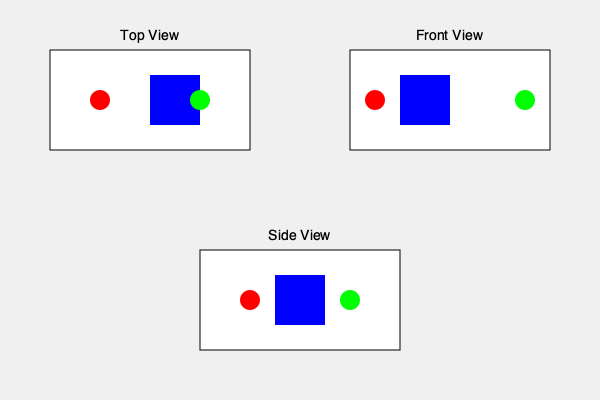Based on the given 2D views of a Goo Goo Dolls stage setup, which of the following 3D configurations is correct?

A) Red spotlight on the left, blue cube in the center, green spotlight on the right
B) Green spotlight on the left, blue cube in the center, red spotlight on the right
C) Blue cube on the left, red spotlight in the center, green spotlight on the right
D) Red spotlight on the left, green spotlight in the center, blue cube on the right To determine the correct 3D stage setup, we need to analyze each 2D view and combine the information:

1. Top View:
   - Red circle (spotlight) on the left
   - Blue square (cube) in the center
   - Green circle (spotlight) on the right

2. Front View:
   - Red circle on the left
   - Blue square in the center
   - Green circle on the right

3. Side View:
   - Two circles (spotlights) with the square (cube) between them

Step-by-step analysis:
1. The top and front views consistently show the red spotlight on the left, blue cube in the center, and green spotlight on the right.
2. The side view confirms that the cube is between the two spotlights.
3. Combining all three views, we can conclude that the correct 3D configuration has the red spotlight on the left, blue cube in the center, and green spotlight on the right.

This configuration matches option A in the question.
Answer: A 